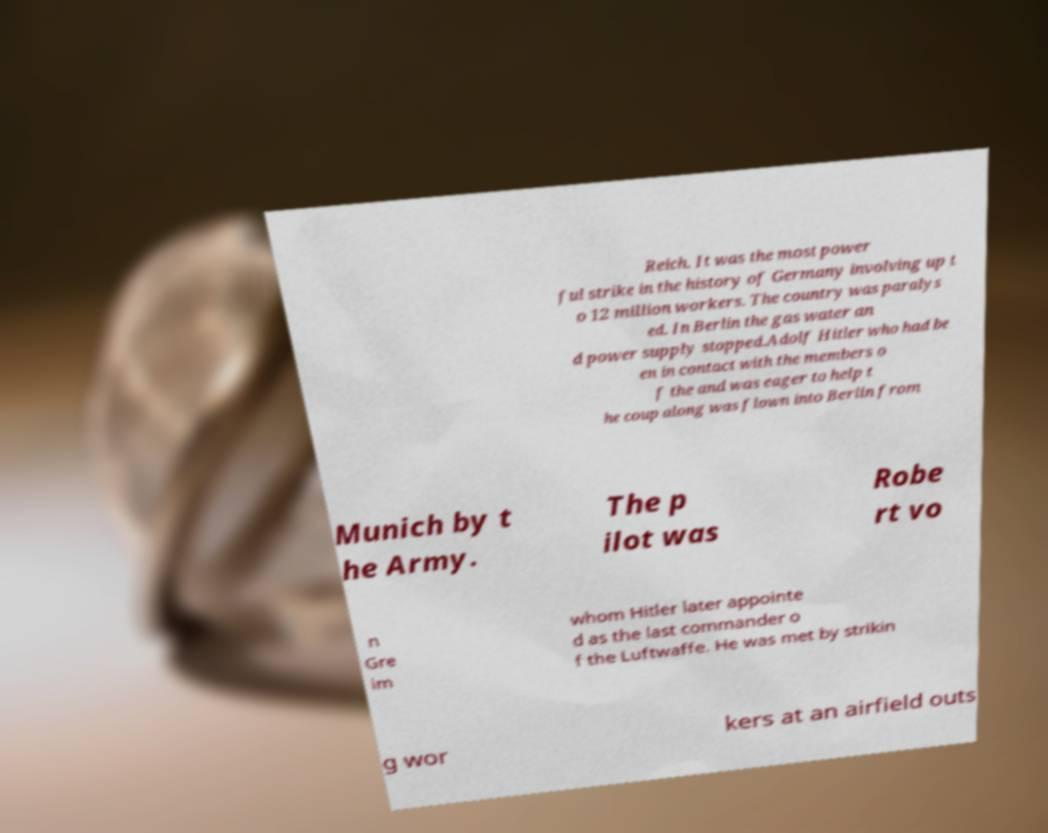Please identify and transcribe the text found in this image. Reich. It was the most power ful strike in the history of Germany involving up t o 12 million workers. The country was paralys ed. In Berlin the gas water an d power supply stopped.Adolf Hitler who had be en in contact with the members o f the and was eager to help t he coup along was flown into Berlin from Munich by t he Army. The p ilot was Robe rt vo n Gre im whom Hitler later appointe d as the last commander o f the Luftwaffe. He was met by strikin g wor kers at an airfield outs 